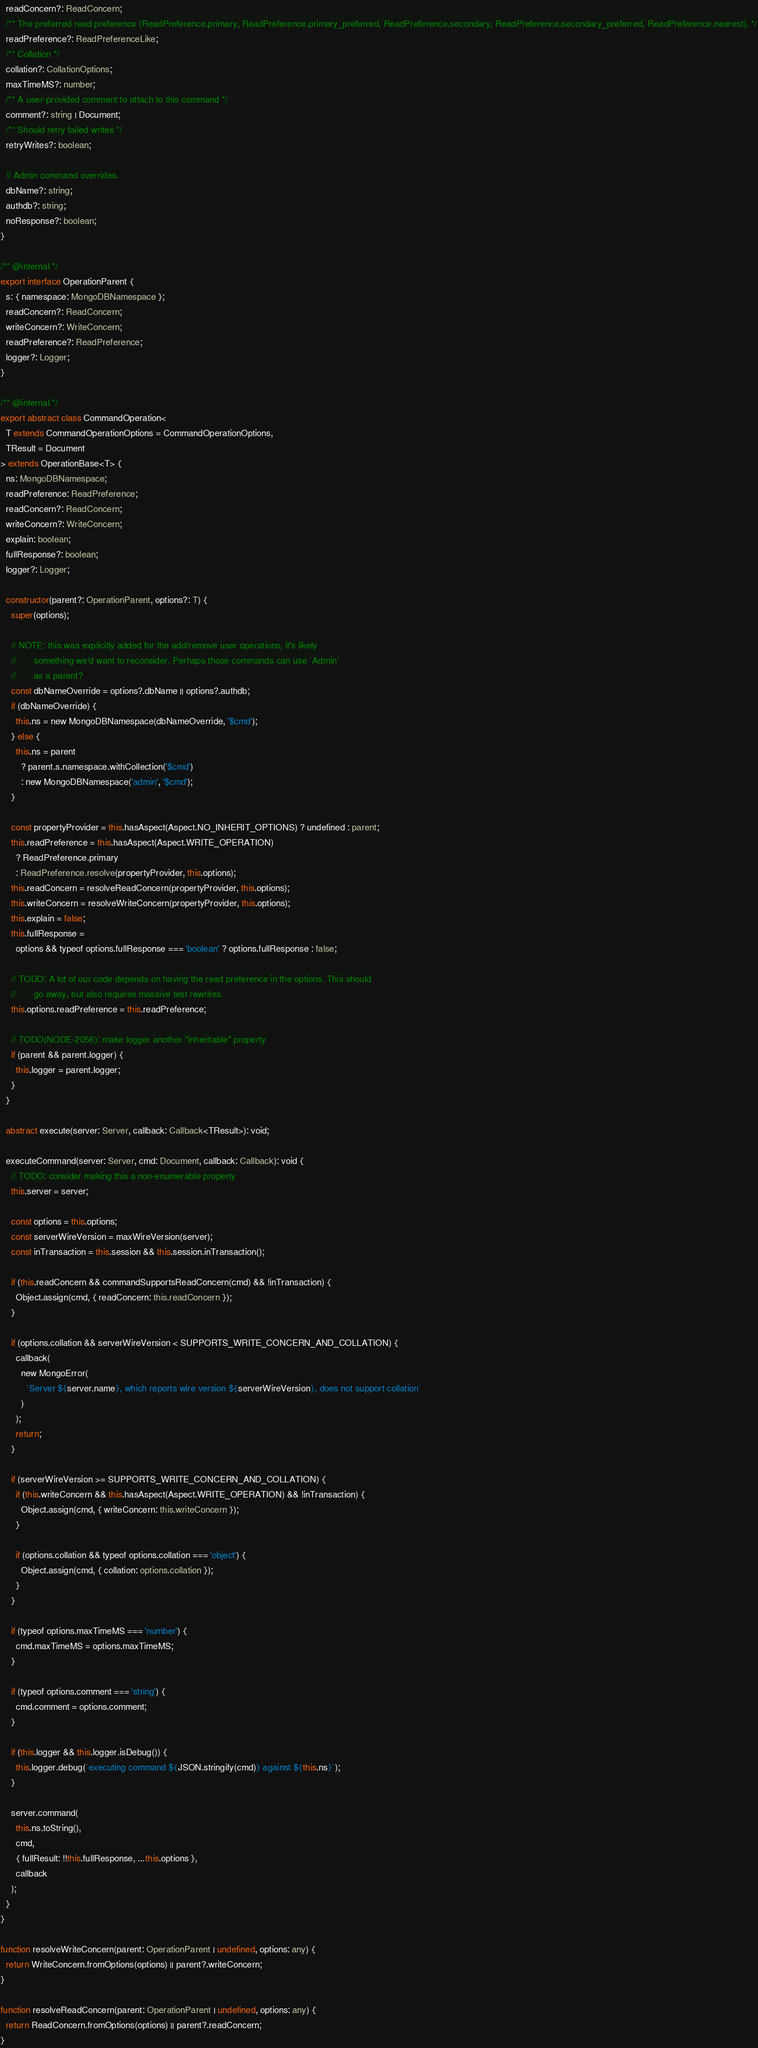<code> <loc_0><loc_0><loc_500><loc_500><_TypeScript_>  readConcern?: ReadConcern;
  /** The preferred read preference (ReadPreference.primary, ReadPreference.primary_preferred, ReadPreference.secondary, ReadPreference.secondary_preferred, ReadPreference.nearest). */
  readPreference?: ReadPreferenceLike;
  /** Collation */
  collation?: CollationOptions;
  maxTimeMS?: number;
  /** A user-provided comment to attach to this command */
  comment?: string | Document;
  /** Should retry failed writes */
  retryWrites?: boolean;

  // Admin command overrides.
  dbName?: string;
  authdb?: string;
  noResponse?: boolean;
}

/** @internal */
export interface OperationParent {
  s: { namespace: MongoDBNamespace };
  readConcern?: ReadConcern;
  writeConcern?: WriteConcern;
  readPreference?: ReadPreference;
  logger?: Logger;
}

/** @internal */
export abstract class CommandOperation<
  T extends CommandOperationOptions = CommandOperationOptions,
  TResult = Document
> extends OperationBase<T> {
  ns: MongoDBNamespace;
  readPreference: ReadPreference;
  readConcern?: ReadConcern;
  writeConcern?: WriteConcern;
  explain: boolean;
  fullResponse?: boolean;
  logger?: Logger;

  constructor(parent?: OperationParent, options?: T) {
    super(options);

    // NOTE: this was explicitly added for the add/remove user operations, it's likely
    //       something we'd want to reconsider. Perhaps those commands can use `Admin`
    //       as a parent?
    const dbNameOverride = options?.dbName || options?.authdb;
    if (dbNameOverride) {
      this.ns = new MongoDBNamespace(dbNameOverride, '$cmd');
    } else {
      this.ns = parent
        ? parent.s.namespace.withCollection('$cmd')
        : new MongoDBNamespace('admin', '$cmd');
    }

    const propertyProvider = this.hasAspect(Aspect.NO_INHERIT_OPTIONS) ? undefined : parent;
    this.readPreference = this.hasAspect(Aspect.WRITE_OPERATION)
      ? ReadPreference.primary
      : ReadPreference.resolve(propertyProvider, this.options);
    this.readConcern = resolveReadConcern(propertyProvider, this.options);
    this.writeConcern = resolveWriteConcern(propertyProvider, this.options);
    this.explain = false;
    this.fullResponse =
      options && typeof options.fullResponse === 'boolean' ? options.fullResponse : false;

    // TODO: A lot of our code depends on having the read preference in the options. This should
    //       go away, but also requires massive test rewrites.
    this.options.readPreference = this.readPreference;

    // TODO(NODE-2056): make logger another "inheritable" property
    if (parent && parent.logger) {
      this.logger = parent.logger;
    }
  }

  abstract execute(server: Server, callback: Callback<TResult>): void;

  executeCommand(server: Server, cmd: Document, callback: Callback): void {
    // TODO: consider making this a non-enumerable property
    this.server = server;

    const options = this.options;
    const serverWireVersion = maxWireVersion(server);
    const inTransaction = this.session && this.session.inTransaction();

    if (this.readConcern && commandSupportsReadConcern(cmd) && !inTransaction) {
      Object.assign(cmd, { readConcern: this.readConcern });
    }

    if (options.collation && serverWireVersion < SUPPORTS_WRITE_CONCERN_AND_COLLATION) {
      callback(
        new MongoError(
          `Server ${server.name}, which reports wire version ${serverWireVersion}, does not support collation`
        )
      );
      return;
    }

    if (serverWireVersion >= SUPPORTS_WRITE_CONCERN_AND_COLLATION) {
      if (this.writeConcern && this.hasAspect(Aspect.WRITE_OPERATION) && !inTransaction) {
        Object.assign(cmd, { writeConcern: this.writeConcern });
      }

      if (options.collation && typeof options.collation === 'object') {
        Object.assign(cmd, { collation: options.collation });
      }
    }

    if (typeof options.maxTimeMS === 'number') {
      cmd.maxTimeMS = options.maxTimeMS;
    }

    if (typeof options.comment === 'string') {
      cmd.comment = options.comment;
    }

    if (this.logger && this.logger.isDebug()) {
      this.logger.debug(`executing command ${JSON.stringify(cmd)} against ${this.ns}`);
    }

    server.command(
      this.ns.toString(),
      cmd,
      { fullResult: !!this.fullResponse, ...this.options },
      callback
    );
  }
}

function resolveWriteConcern(parent: OperationParent | undefined, options: any) {
  return WriteConcern.fromOptions(options) || parent?.writeConcern;
}

function resolveReadConcern(parent: OperationParent | undefined, options: any) {
  return ReadConcern.fromOptions(options) || parent?.readConcern;
}
</code> 